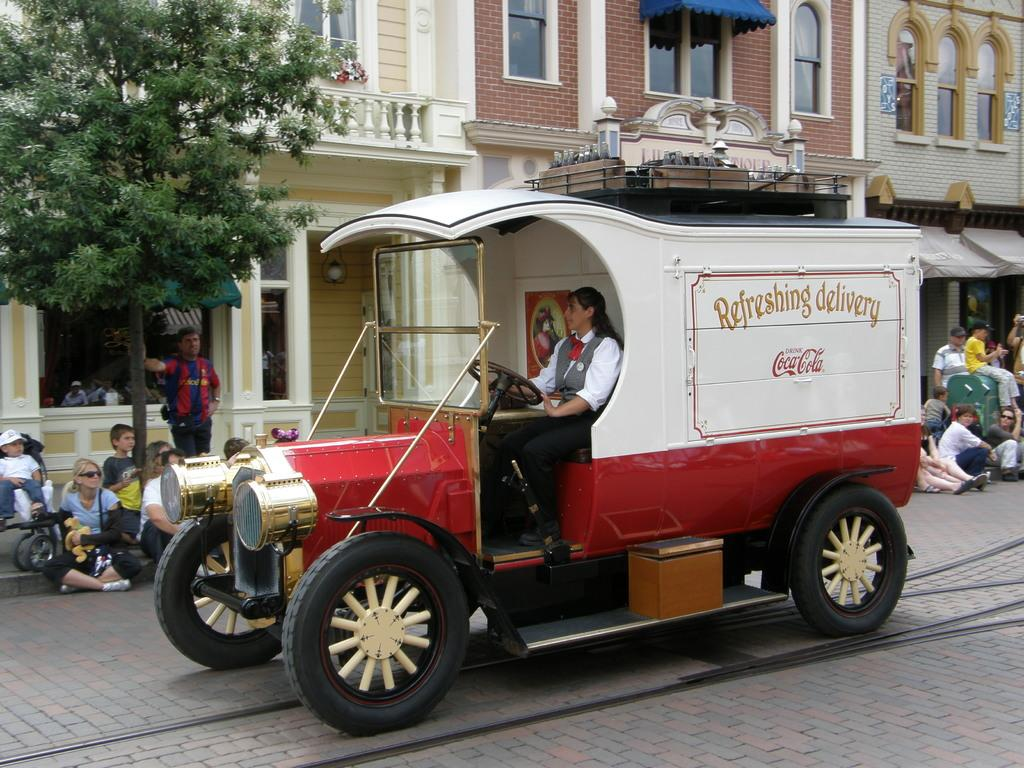What can be seen in the background of the image? There are buildings and people in the background of the image. What are the people in the background doing? Some people are standing, and some are sitting in the background of the image. What is on the left side of the image? There is a tree on the left side of the image. What is present in the image besides the tree and people? There is a vehicle in the image. Who is inside the vehicle? A woman is sitting in the vehicle. What is the woman doing while sitting in the vehicle? The woman is holding a steering wheel. What type of square is visible in the image? There is no square present in the image. What is being served for dinner in the image? There is no dinner or food being served in the image. 